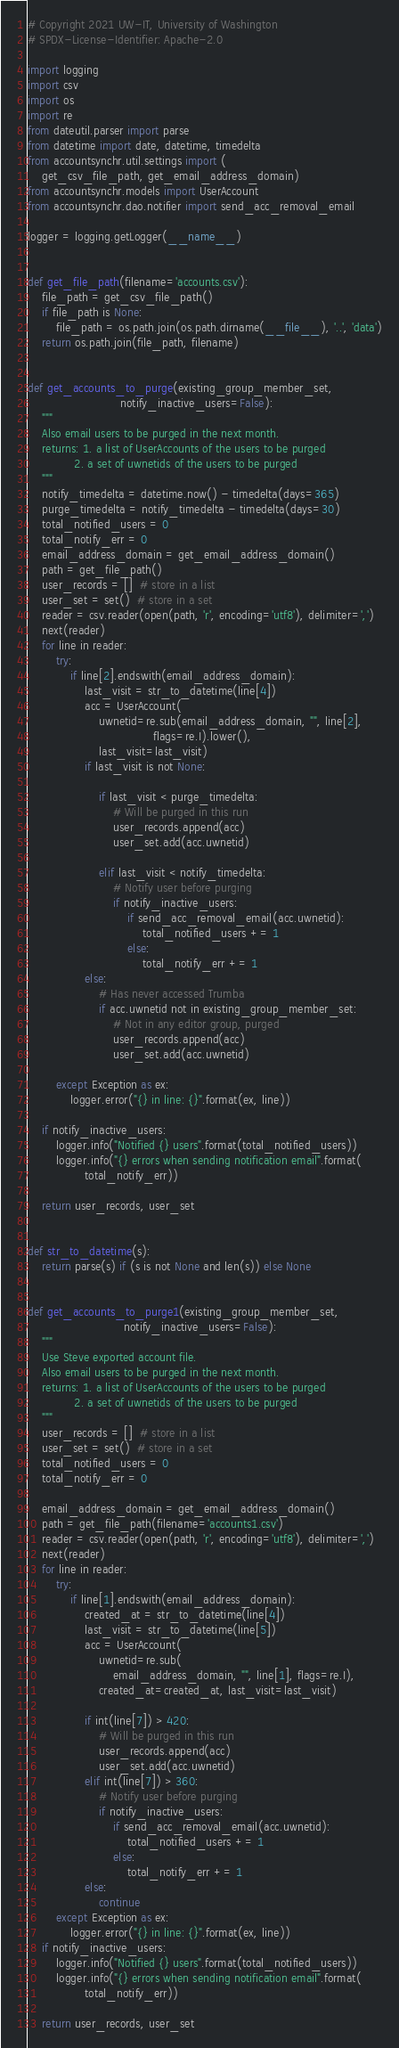Convert code to text. <code><loc_0><loc_0><loc_500><loc_500><_Python_># Copyright 2021 UW-IT, University of Washington
# SPDX-License-Identifier: Apache-2.0

import logging
import csv
import os
import re
from dateutil.parser import parse
from datetime import date, datetime, timedelta
from accountsynchr.util.settings import (
    get_csv_file_path, get_email_address_domain)
from accountsynchr.models import UserAccount
from accountsynchr.dao.notifier import send_acc_removal_email

logger = logging.getLogger(__name__)


def get_file_path(filename='accounts.csv'):
    file_path = get_csv_file_path()
    if file_path is None:
        file_path = os.path.join(os.path.dirname(__file__), '..', 'data')
    return os.path.join(file_path, filename)


def get_accounts_to_purge(existing_group_member_set,
                          notify_inactive_users=False):
    """
    Also email users to be purged in the next month.
    returns: 1. a list of UserAccounts of the users to be purged
             2. a set of uwnetids of the users to be purged
    """
    notify_timedelta = datetime.now() - timedelta(days=365)
    purge_timedelta = notify_timedelta - timedelta(days=30)
    total_notified_users = 0
    total_notify_err = 0
    email_address_domain = get_email_address_domain()
    path = get_file_path()
    user_records = []  # store in a list
    user_set = set()  # store in a set
    reader = csv.reader(open(path, 'r', encoding='utf8'), delimiter=',')
    next(reader)
    for line in reader:
        try:
            if line[2].endswith(email_address_domain):
                last_visit = str_to_datetime(line[4])
                acc = UserAccount(
                    uwnetid=re.sub(email_address_domain, "", line[2],
                                   flags=re.I).lower(),
                    last_visit=last_visit)
                if last_visit is not None:

                    if last_visit < purge_timedelta:
                        # Will be purged in this run
                        user_records.append(acc)
                        user_set.add(acc.uwnetid)

                    elif last_visit < notify_timedelta:
                        # Notify user before purging
                        if notify_inactive_users:
                            if send_acc_removal_email(acc.uwnetid):
                                total_notified_users += 1
                            else:
                                total_notify_err += 1
                else:
                    # Has never accessed Trumba
                    if acc.uwnetid not in existing_group_member_set:
                        # Not in any editor group, purged
                        user_records.append(acc)
                        user_set.add(acc.uwnetid)

        except Exception as ex:
            logger.error("{} in line: {}".format(ex, line))

    if notify_inactive_users:
        logger.info("Notified {} users".format(total_notified_users))
        logger.info("{} errors when sending notification email".format(
                total_notify_err))

    return user_records, user_set


def str_to_datetime(s):
    return parse(s) if (s is not None and len(s)) else None


def get_accounts_to_purge1(existing_group_member_set,
                           notify_inactive_users=False):
    """
    Use Steve exported account file.
    Also email users to be purged in the next month.
    returns: 1. a list of UserAccounts of the users to be purged
             2. a set of uwnetids of the users to be purged
    """
    user_records = []  # store in a list
    user_set = set()  # store in a set
    total_notified_users = 0
    total_notify_err = 0

    email_address_domain = get_email_address_domain()
    path = get_file_path(filename='accounts1.csv')
    reader = csv.reader(open(path, 'r', encoding='utf8'), delimiter=',')
    next(reader)
    for line in reader:
        try:
            if line[1].endswith(email_address_domain):
                created_at = str_to_datetime(line[4])
                last_visit = str_to_datetime(line[5])
                acc = UserAccount(
                    uwnetid=re.sub(
                        email_address_domain, "", line[1], flags=re.I),
                    created_at=created_at, last_visit=last_visit)

                if int(line[7]) > 420:
                    # Will be purged in this run
                    user_records.append(acc)
                    user_set.add(acc.uwnetid)
                elif int(line[7]) > 360:
                    # Notify user before purging
                    if notify_inactive_users:
                        if send_acc_removal_email(acc.uwnetid):
                            total_notified_users += 1
                        else:
                            total_notify_err += 1
                else:
                    continue
        except Exception as ex:
            logger.error("{} in line: {}".format(ex, line))
    if notify_inactive_users:
        logger.info("Notified {} users".format(total_notified_users))
        logger.info("{} errors when sending notification email".format(
                total_notify_err))

    return user_records, user_set
</code> 